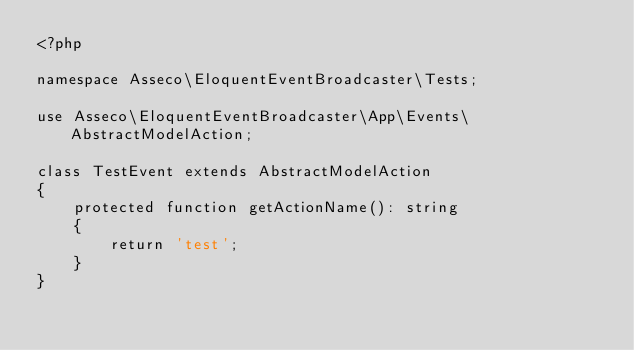Convert code to text. <code><loc_0><loc_0><loc_500><loc_500><_PHP_><?php

namespace Asseco\EloquentEventBroadcaster\Tests;

use Asseco\EloquentEventBroadcaster\App\Events\AbstractModelAction;

class TestEvent extends AbstractModelAction
{
    protected function getActionName(): string
    {
        return 'test';
    }
}
</code> 